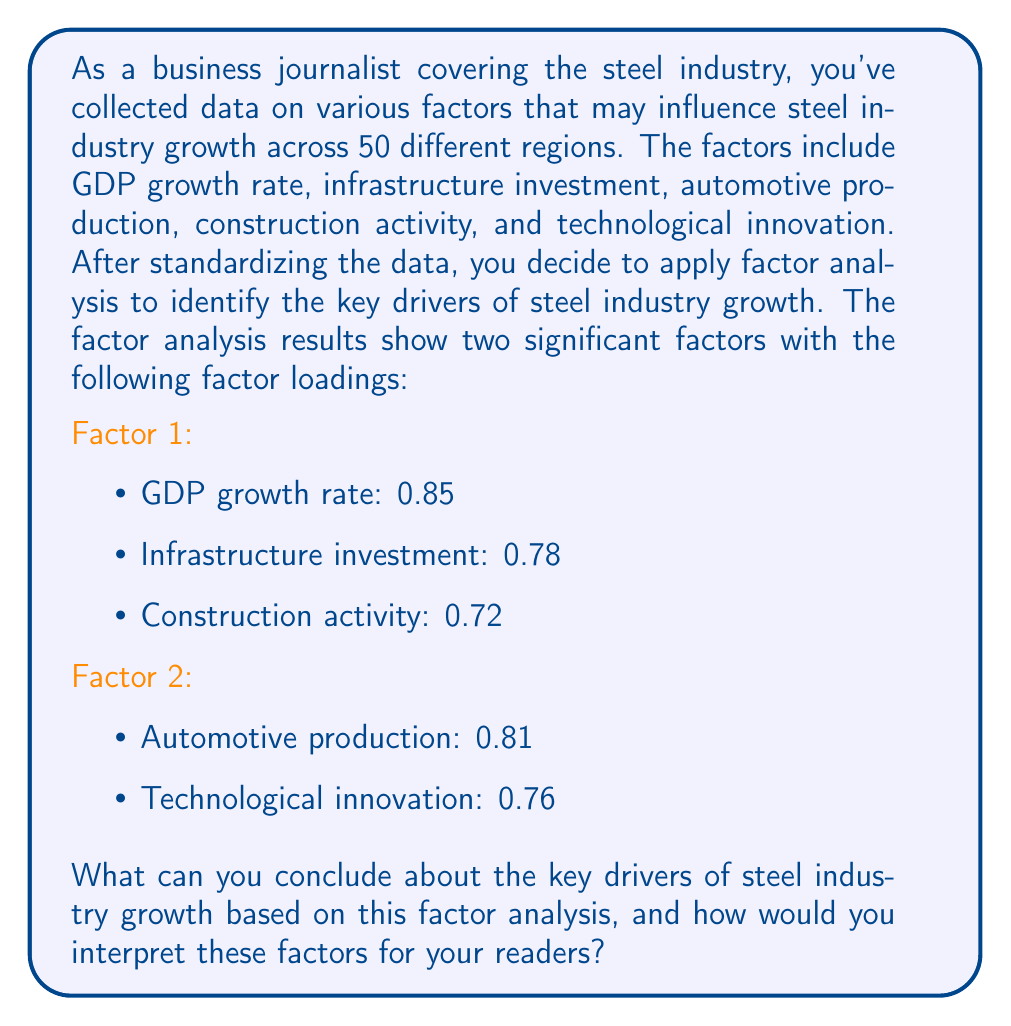Can you solve this math problem? To interpret the results of the factor analysis, we need to follow these steps:

1. Understand the factor loadings:
   Factor loadings represent the correlation between each variable and the underlying factor. Generally, loadings above 0.7 are considered significant.

2. Identify the variables associated with each factor:
   Factor 1: GDP growth rate, infrastructure investment, and construction activity
   Factor 2: Automotive production and technological innovation

3. Interpret the factors:
   Factor 1 appears to represent "Economic and Construction Activity"
   Factor 2 seems to represent "Industrial Advancement"

4. Calculate the proportion of variance explained by each factor:
   This step typically involves examining eigenvalues, but since they're not provided, we'll focus on the interpretation based on the loadings.

5. Interpret the results in the context of the steel industry:
   
   Factor 1 (Economic and Construction Activity):
   - This factor combines GDP growth, infrastructure investment, and construction activity, which are all closely related to overall economic growth and development.
   - These variables are strong indicators of demand for steel in construction and infrastructure projects.
   - The high loadings (0.85, 0.78, and 0.72) suggest that this factor is a significant driver of steel industry growth.

   Factor 2 (Industrial Advancement):
   - This factor combines automotive production and technological innovation.
   - It represents the demand for steel in manufacturing, particularly in the automotive sector, and the role of innovation in driving industry growth.
   - The high loadings (0.81 and 0.76) indicate that this factor is also an important driver of steel industry growth.

6. Conclusion:
   The factor analysis has identified two key drivers of steel industry growth:
   a) Economic and construction activity
   b) Industrial advancement, particularly in the automotive sector and through technological innovation

   These factors explain a significant portion of the variance in steel industry growth across different regions.

For a business journalist, this analysis provides a framework to explain the complex drivers of steel industry growth in a more accessible way to readers. It allows for grouping related variables and identifying underlying trends that might not be immediately apparent from individual variables.
Answer: The factor analysis identifies two key drivers of steel industry growth:
1. Economic and Construction Activity (Factor 1): encompassing GDP growth, infrastructure investment, and construction activity.
2. Industrial Advancement (Factor 2): representing automotive production and technological innovation.

These factors provide a simplified framework for understanding the complex drivers of steel industry growth across different regions, highlighting the importance of both overall economic development and specific industrial advancements in driving demand for steel. 